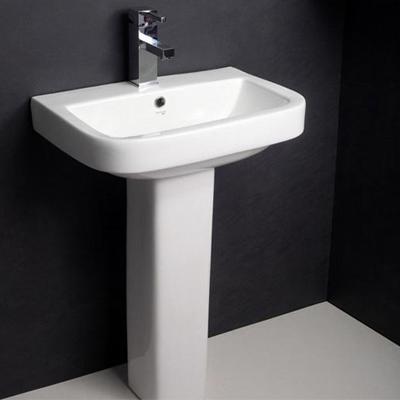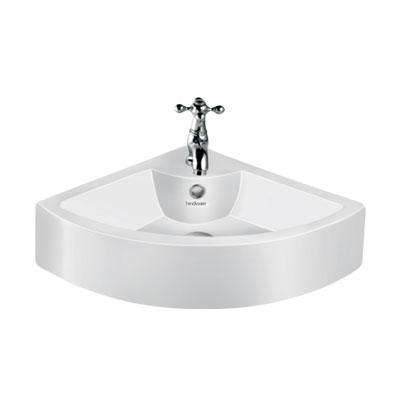The first image is the image on the left, the second image is the image on the right. Evaluate the accuracy of this statement regarding the images: "At least one sink has no background, just plain white.". Is it true? Answer yes or no. Yes. 